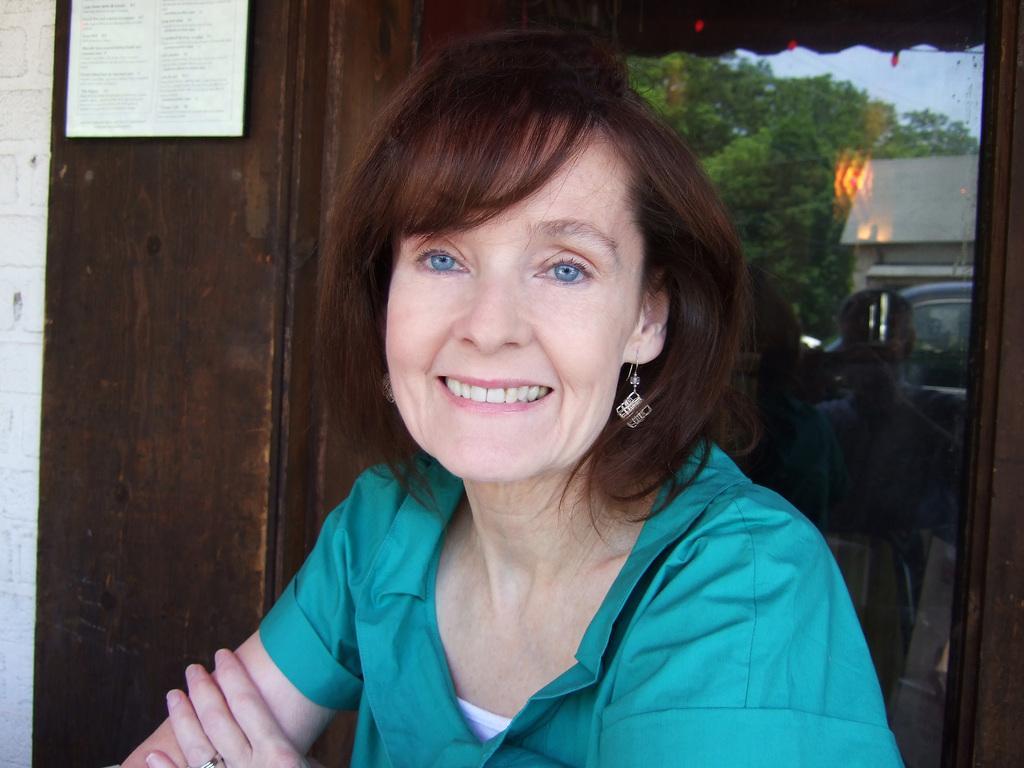In one or two sentences, can you explain what this image depicts? In this image we can see a woman is smiling and wearing green color shirt. Behind brown color door is there and glass is present. In glass trees, car and house reflection is present. 